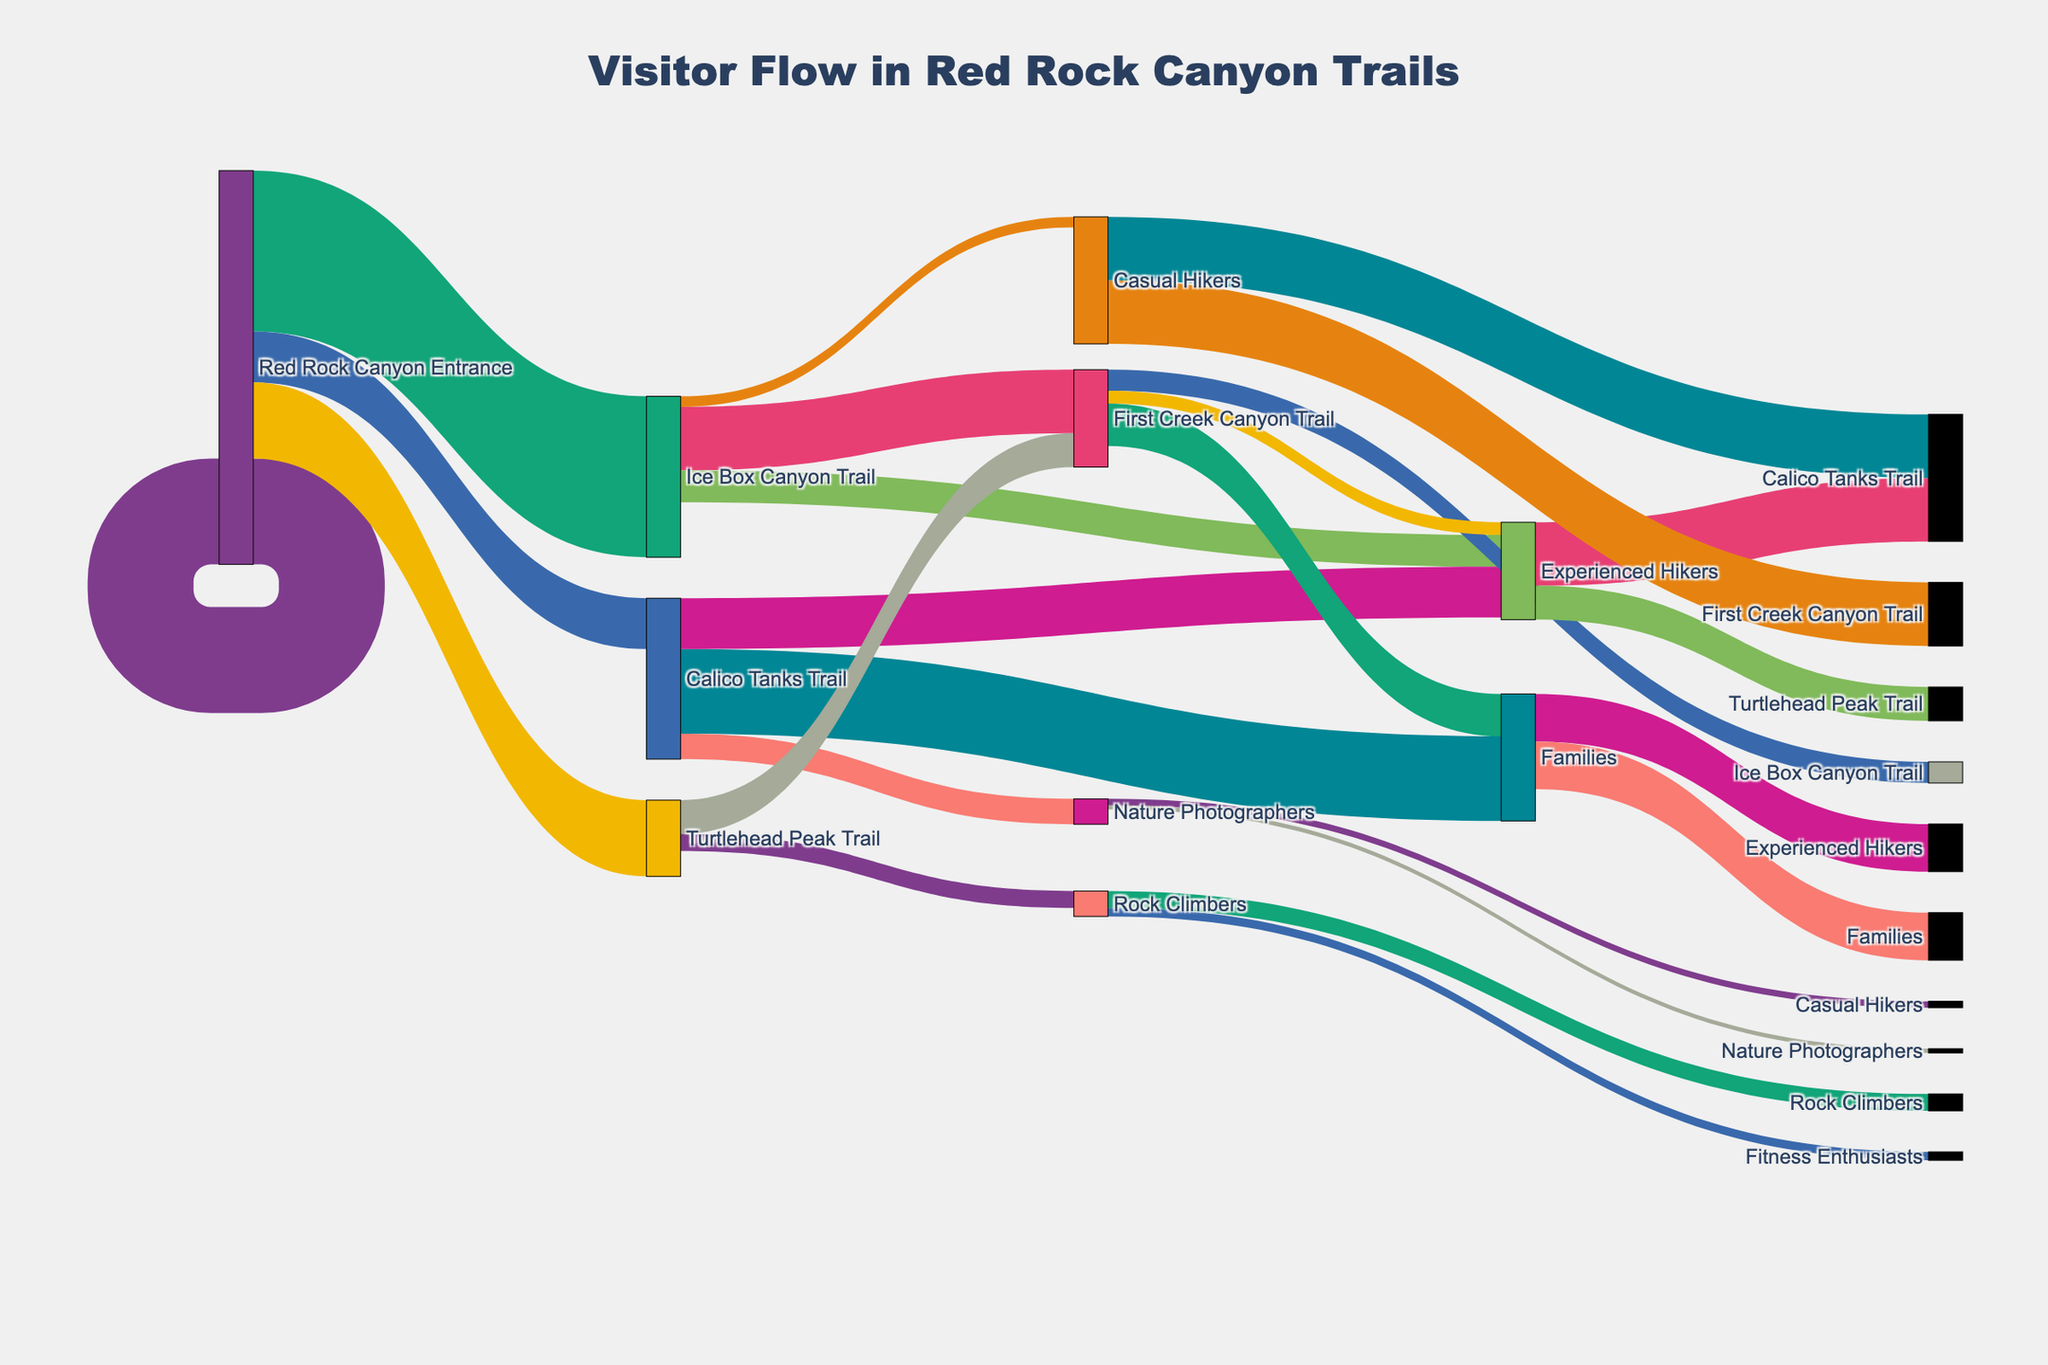what's the title of the figure? The title is typically located at the top center of the figure and is set based on the provided code.
Answer: Visitor Flow in Red Rock Canyon Trails Which trail has the highest number of visitors entering from Red Rock Canyon Entrance? To determine this, look at the flows from "Red Rock Canyon Entrance" and identify which has the highest value.
Answer: Calico Tanks Trail How many visitors labeled as "Families" went to Ice Box Canyon Trail? Check the flow from "Ice Box Canyon Trail" to "Families" to find the value.
Answer: 750 What is the total number of visitors that chose the Ice Box Canyon Trail? Sum the values of all flows that target "Ice Box Canyon Trail". 2500 (entrance to Ice Box Canyon Trail).
Answer: 2500 How many more visitors chose Calico Tanks Trail over Ice Box Canyon Trail? Subtract the number of visitors on Ice Box Canyon Trail from those on Calico Tanks Trail. 3800 (Calico Tanks) - 2500 (Ice Box)
Answer: 1300 Which group has the highest proportion of visitors on Calico Tanks Trail? Identify the group with the largest flow from "Calico Tanks Trail".
Answer: Casual Hikers How many visitors on Turtlehead Peak Trail are categorized as Fitness Enthusiasts? Check the flow from "Turtlehead Peak Trail" to "Fitness Enthusiasts" to find the value.
Answer: 400 What is the sum of all visitors labeled "Experienced Hikers" across all trails? Sum the values flowing into "Experienced Hikers" from any trail. 1500 (Ice Box) + 800 (Turtlehead)
Answer: 2300 Which age group categorizes the majority of Experienced Hikers? Check the group with the largest flow from "Experienced Hikers".
Answer: 30-50 Age Group Which visitor group splits evenly into two demographics, and what are these demographics? Identify the visitor group with equal flows to two demographics. "Families" splits evenly into "Children" and "Adults" with the same value.
Answer: Families, Children & Adults 